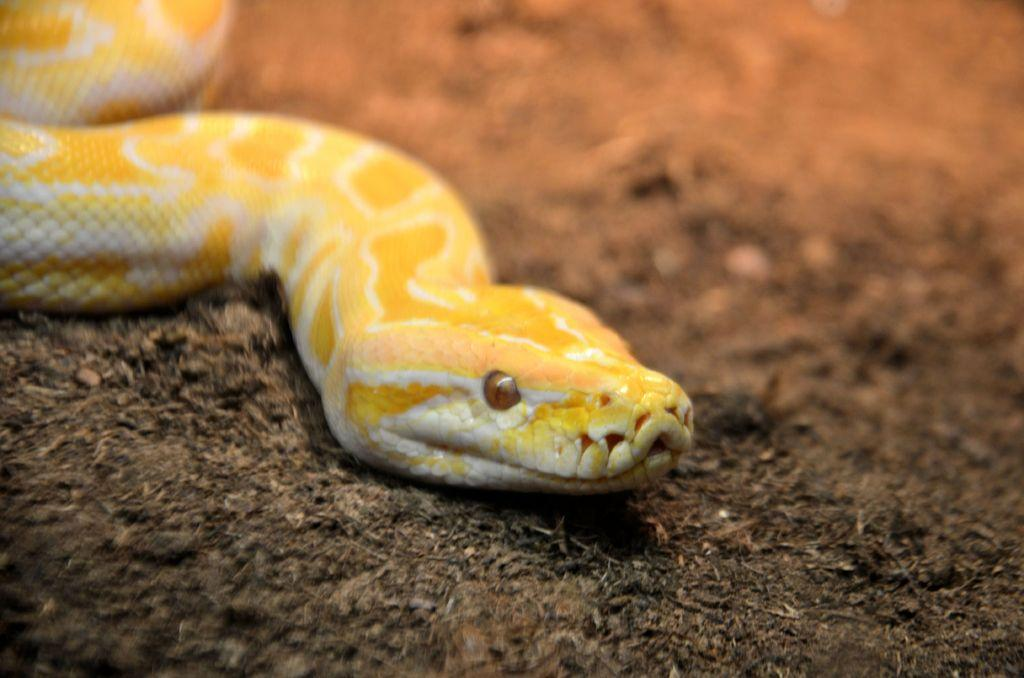What type of animal is present in the image? There is a snake in the image. Can you see a trail of mittens left by the snake in the image? There is no trail of mittens left by the snake in the image, as snakes do not wear mittens. 